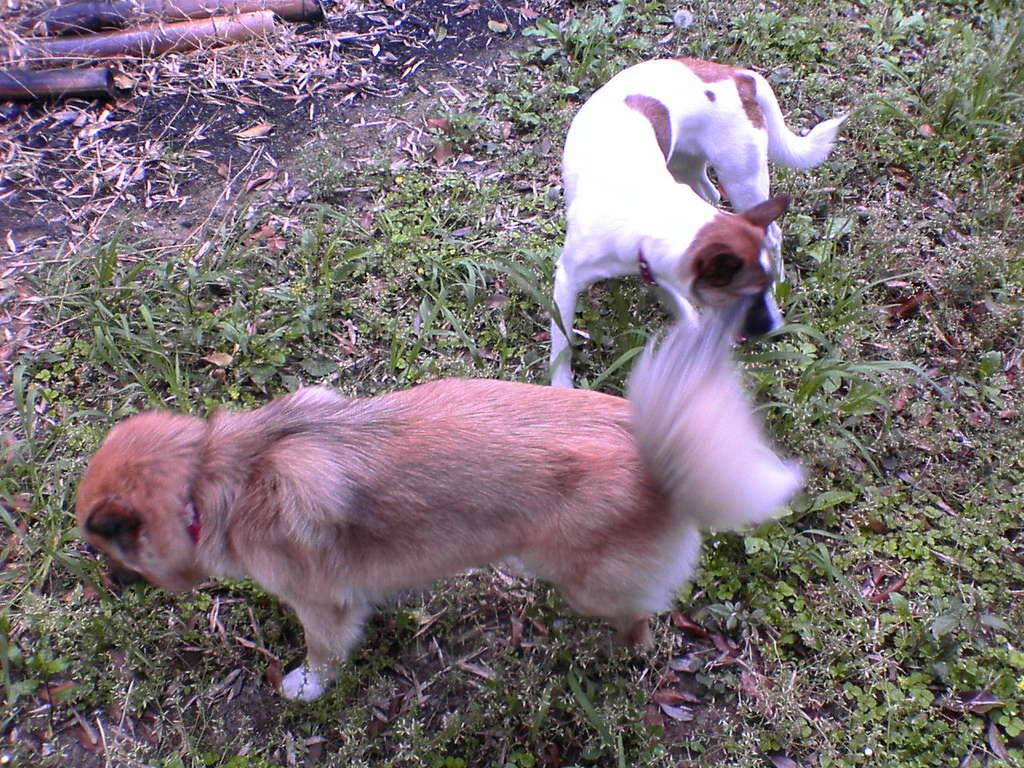How many animals are present in the image? There are two animals in the image. What is the position of the animals in the image? The animals are on the ground. What colors can be seen on the animals in the image? The animals are in white and brown color. What else can be seen on the ground in the image? There are sticks and grass on the ground. How many ladybugs are crawling on the animals in the image? There are no ladybugs present in the image. What type of servant is attending to the animals in the image? There is no servant present in the image; the animals are on the ground without any human assistance. 